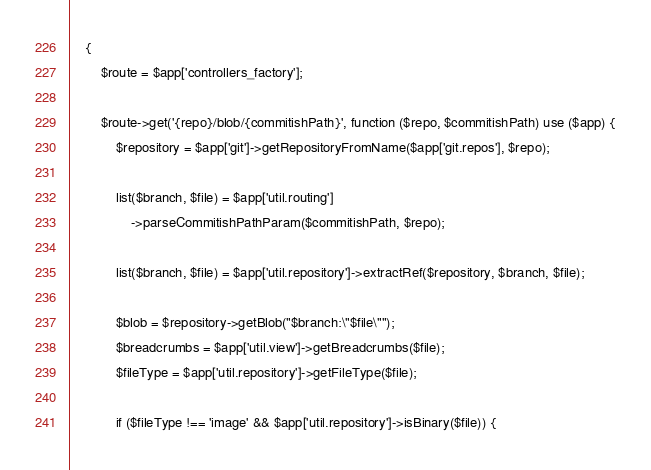Convert code to text. <code><loc_0><loc_0><loc_500><loc_500><_PHP_>    {
        $route = $app['controllers_factory'];

        $route->get('{repo}/blob/{commitishPath}', function ($repo, $commitishPath) use ($app) {
            $repository = $app['git']->getRepositoryFromName($app['git.repos'], $repo);

            list($branch, $file) = $app['util.routing']
                ->parseCommitishPathParam($commitishPath, $repo);

            list($branch, $file) = $app['util.repository']->extractRef($repository, $branch, $file);

            $blob = $repository->getBlob("$branch:\"$file\"");
            $breadcrumbs = $app['util.view']->getBreadcrumbs($file);
            $fileType = $app['util.repository']->getFileType($file);

            if ($fileType !== 'image' && $app['util.repository']->isBinary($file)) {</code> 